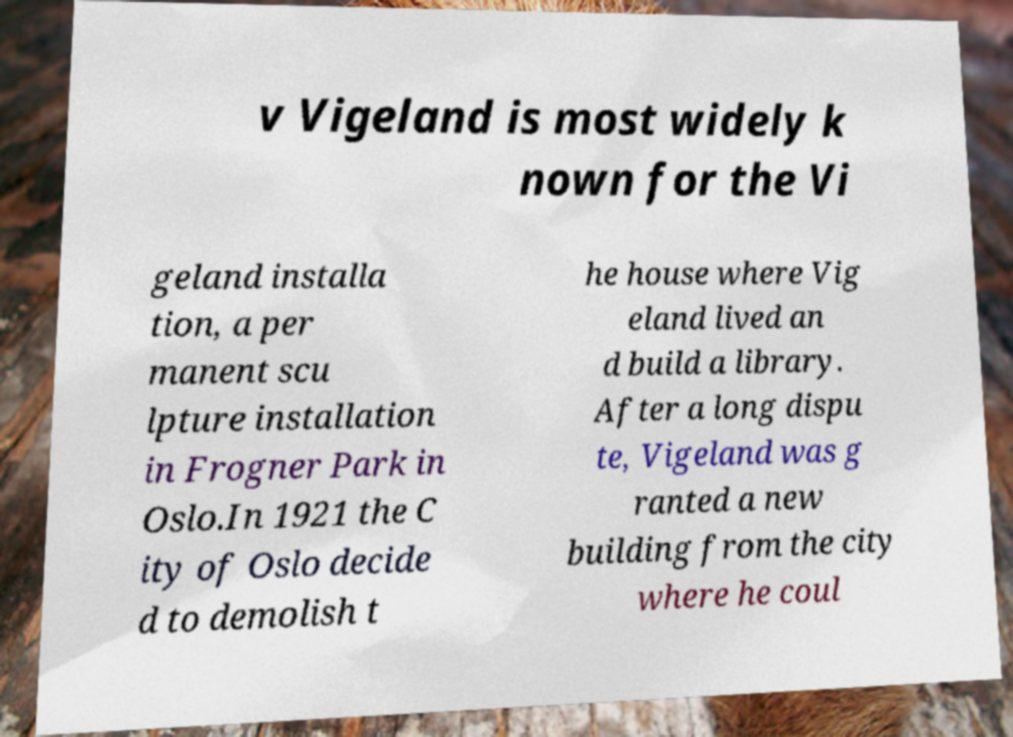Please read and relay the text visible in this image. What does it say? v Vigeland is most widely k nown for the Vi geland installa tion, a per manent scu lpture installation in Frogner Park in Oslo.In 1921 the C ity of Oslo decide d to demolish t he house where Vig eland lived an d build a library. After a long dispu te, Vigeland was g ranted a new building from the city where he coul 